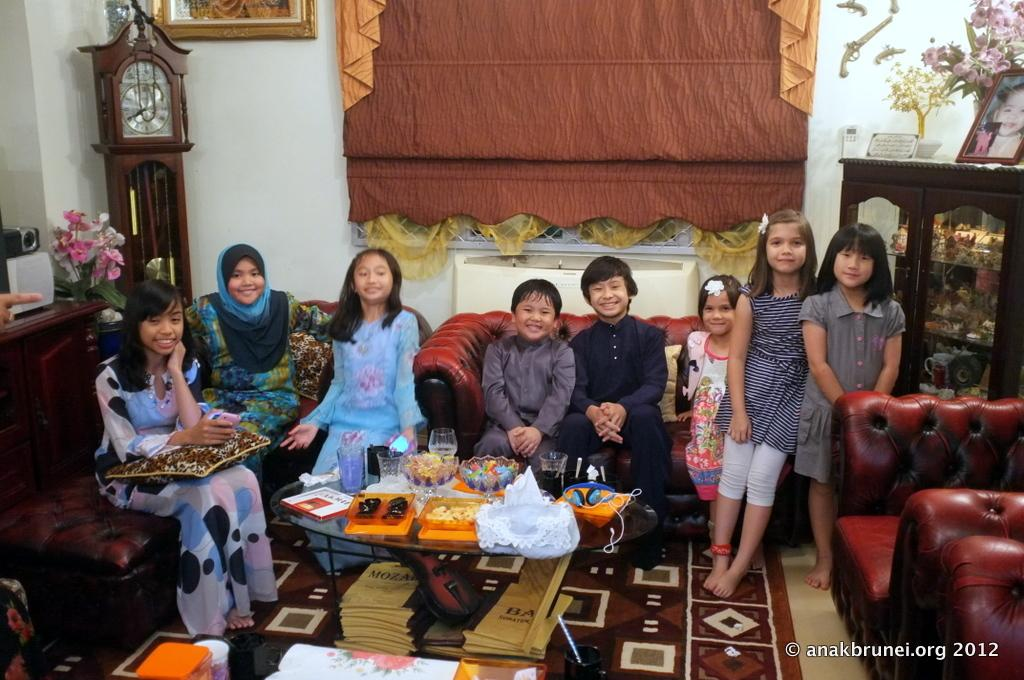What object in the image can be used to tell time? There is a clock in the image that can be used to tell time. What type of background can be seen in the image? There is a wall in the image that serves as the background. What is hanging on the wall in the image? There is a photo frame hanging on the wall in the image. What type of decorative element is present in the image? There are flowers in the image, which serve as a decorative element. What type of furniture can be seen in the image? There are people sitting on a sofa in the image, and there is also a table present. What items are stored under the table in the image? There are books under the table in the image, which are stored under the table. How many birds are sitting on the clock in the image? There are no birds present in the image, let alone sitting on the clock. 